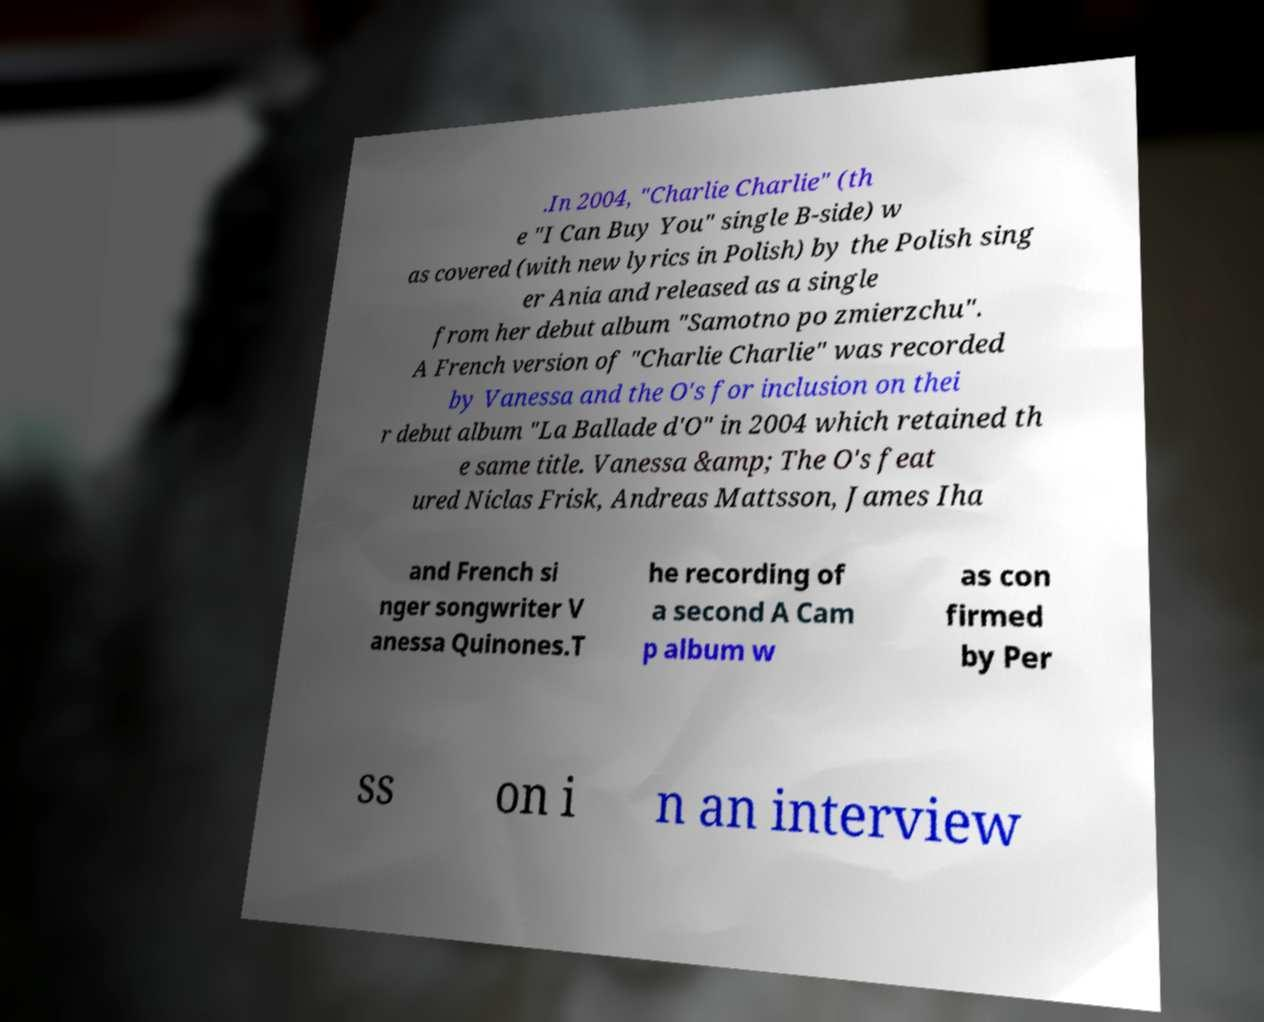Could you extract and type out the text from this image? .In 2004, "Charlie Charlie" (th e "I Can Buy You" single B-side) w as covered (with new lyrics in Polish) by the Polish sing er Ania and released as a single from her debut album "Samotno po zmierzchu". A French version of "Charlie Charlie" was recorded by Vanessa and the O's for inclusion on thei r debut album "La Ballade d'O" in 2004 which retained th e same title. Vanessa &amp; The O's feat ured Niclas Frisk, Andreas Mattsson, James Iha and French si nger songwriter V anessa Quinones.T he recording of a second A Cam p album w as con firmed by Per ss on i n an interview 